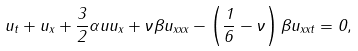Convert formula to latex. <formula><loc_0><loc_0><loc_500><loc_500>u _ { t } + u _ { x } + \frac { 3 } { 2 } \alpha u u _ { x } + \nu \beta u _ { x x x } - \left ( \frac { 1 } { 6 } - \nu \right ) \beta u _ { x x t } = 0 ,</formula> 